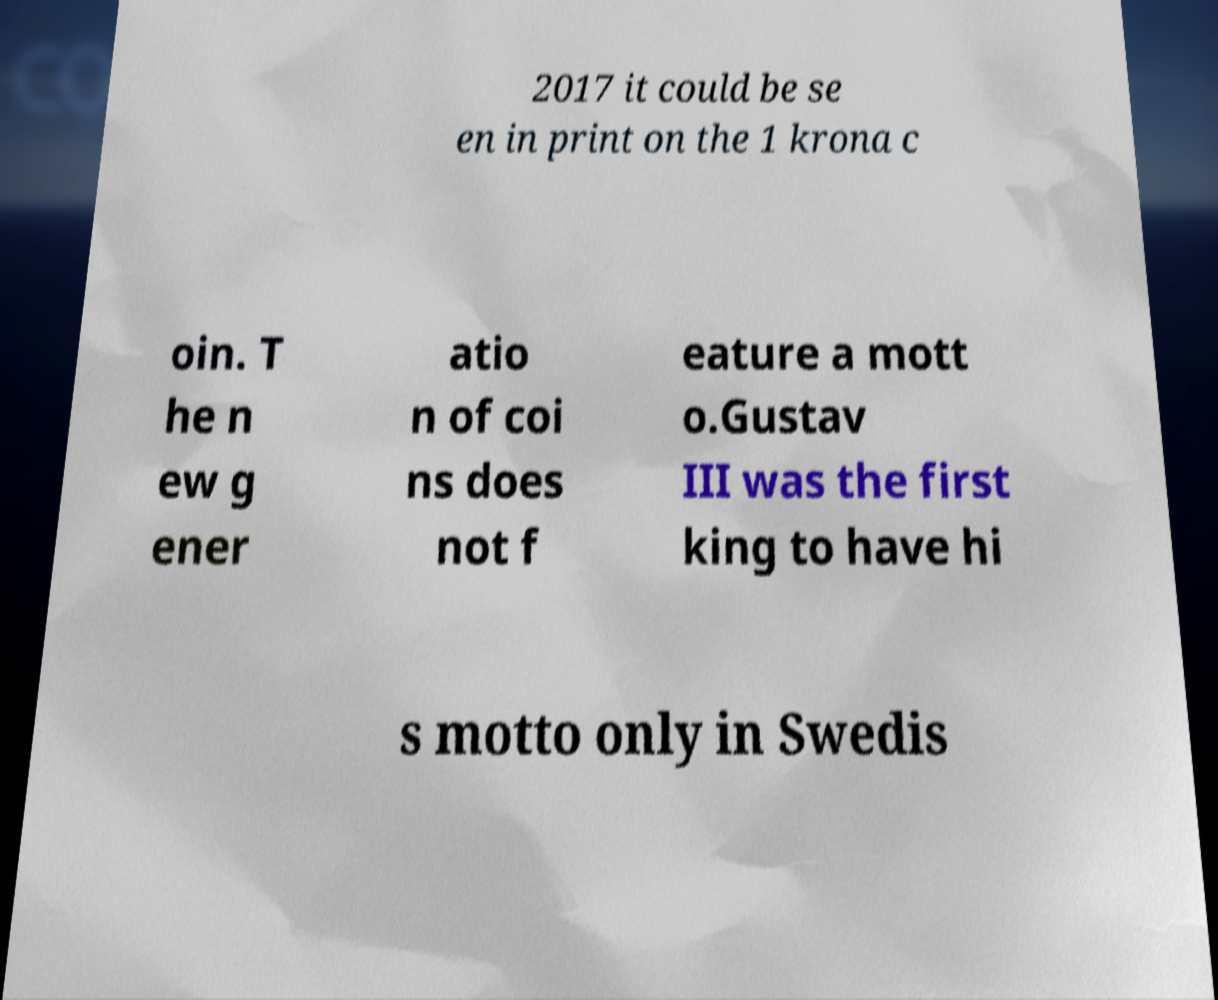For documentation purposes, I need the text within this image transcribed. Could you provide that? 2017 it could be se en in print on the 1 krona c oin. T he n ew g ener atio n of coi ns does not f eature a mott o.Gustav III was the first king to have hi s motto only in Swedis 